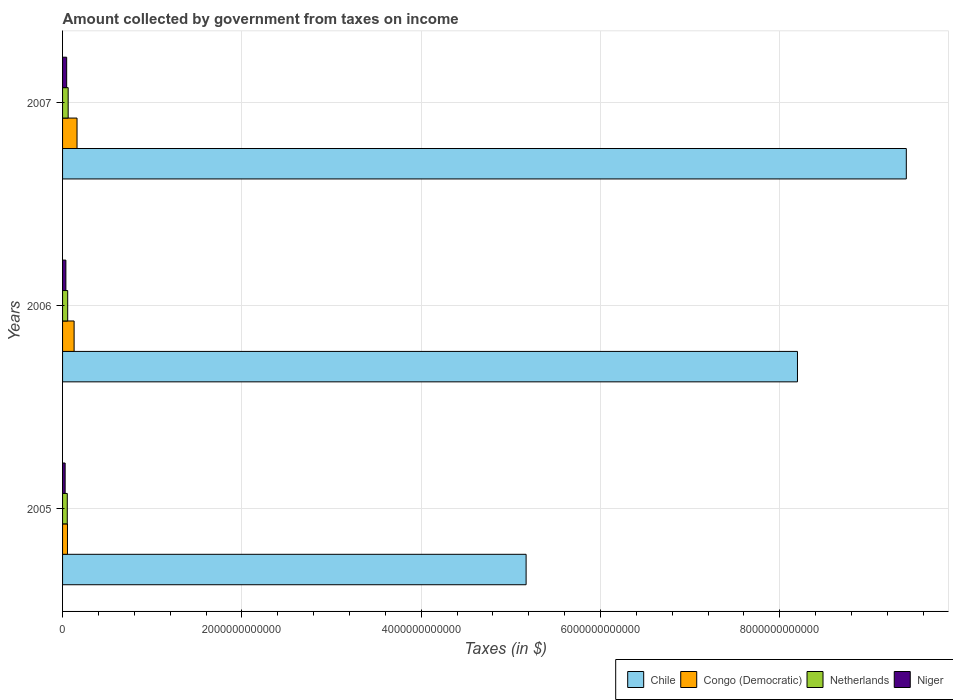How many different coloured bars are there?
Give a very brief answer. 4. How many groups of bars are there?
Offer a very short reply. 3. How many bars are there on the 2nd tick from the top?
Offer a terse response. 4. How many bars are there on the 2nd tick from the bottom?
Make the answer very short. 4. What is the label of the 1st group of bars from the top?
Your response must be concise. 2007. In how many cases, is the number of bars for a given year not equal to the number of legend labels?
Your response must be concise. 0. What is the amount collected by government from taxes on income in Netherlands in 2007?
Your answer should be compact. 6.25e+1. Across all years, what is the maximum amount collected by government from taxes on income in Niger?
Offer a terse response. 4.58e+1. Across all years, what is the minimum amount collected by government from taxes on income in Congo (Democratic)?
Offer a terse response. 5.48e+1. In which year was the amount collected by government from taxes on income in Chile maximum?
Ensure brevity in your answer.  2007. In which year was the amount collected by government from taxes on income in Chile minimum?
Your answer should be compact. 2005. What is the total amount collected by government from taxes on income in Netherlands in the graph?
Offer a terse response. 1.72e+11. What is the difference between the amount collected by government from taxes on income in Netherlands in 2006 and that in 2007?
Keep it short and to the point. -5.07e+09. What is the difference between the amount collected by government from taxes on income in Chile in 2006 and the amount collected by government from taxes on income in Netherlands in 2005?
Your answer should be very brief. 8.15e+12. What is the average amount collected by government from taxes on income in Netherlands per year?
Your answer should be compact. 5.75e+1. In the year 2007, what is the difference between the amount collected by government from taxes on income in Niger and amount collected by government from taxes on income in Netherlands?
Provide a short and direct response. -1.67e+1. What is the ratio of the amount collected by government from taxes on income in Congo (Democratic) in 2006 to that in 2007?
Make the answer very short. 0.8. Is the difference between the amount collected by government from taxes on income in Niger in 2005 and 2006 greater than the difference between the amount collected by government from taxes on income in Netherlands in 2005 and 2006?
Offer a very short reply. No. What is the difference between the highest and the second highest amount collected by government from taxes on income in Niger?
Make the answer very short. 8.88e+09. What is the difference between the highest and the lowest amount collected by government from taxes on income in Netherlands?
Your answer should be compact. 9.82e+09. What does the 2nd bar from the bottom in 2006 represents?
Provide a short and direct response. Congo (Democratic). How many bars are there?
Make the answer very short. 12. How many years are there in the graph?
Offer a terse response. 3. What is the difference between two consecutive major ticks on the X-axis?
Provide a short and direct response. 2.00e+12. Does the graph contain any zero values?
Ensure brevity in your answer.  No. Does the graph contain grids?
Provide a short and direct response. Yes. Where does the legend appear in the graph?
Provide a succinct answer. Bottom right. How many legend labels are there?
Your answer should be very brief. 4. How are the legend labels stacked?
Ensure brevity in your answer.  Horizontal. What is the title of the graph?
Provide a short and direct response. Amount collected by government from taxes on income. What is the label or title of the X-axis?
Your answer should be very brief. Taxes (in $). What is the Taxes (in $) in Chile in 2005?
Your response must be concise. 5.17e+12. What is the Taxes (in $) of Congo (Democratic) in 2005?
Your response must be concise. 5.48e+1. What is the Taxes (in $) in Netherlands in 2005?
Give a very brief answer. 5.26e+1. What is the Taxes (in $) of Niger in 2005?
Ensure brevity in your answer.  2.86e+1. What is the Taxes (in $) in Chile in 2006?
Your answer should be very brief. 8.20e+12. What is the Taxes (in $) of Congo (Democratic) in 2006?
Your response must be concise. 1.29e+11. What is the Taxes (in $) of Netherlands in 2006?
Ensure brevity in your answer.  5.74e+1. What is the Taxes (in $) in Niger in 2006?
Ensure brevity in your answer.  3.69e+1. What is the Taxes (in $) of Chile in 2007?
Provide a succinct answer. 9.41e+12. What is the Taxes (in $) of Congo (Democratic) in 2007?
Offer a terse response. 1.61e+11. What is the Taxes (in $) of Netherlands in 2007?
Give a very brief answer. 6.25e+1. What is the Taxes (in $) in Niger in 2007?
Your answer should be very brief. 4.58e+1. Across all years, what is the maximum Taxes (in $) in Chile?
Give a very brief answer. 9.41e+12. Across all years, what is the maximum Taxes (in $) of Congo (Democratic)?
Your response must be concise. 1.61e+11. Across all years, what is the maximum Taxes (in $) of Netherlands?
Ensure brevity in your answer.  6.25e+1. Across all years, what is the maximum Taxes (in $) in Niger?
Your answer should be compact. 4.58e+1. Across all years, what is the minimum Taxes (in $) in Chile?
Provide a short and direct response. 5.17e+12. Across all years, what is the minimum Taxes (in $) of Congo (Democratic)?
Make the answer very short. 5.48e+1. Across all years, what is the minimum Taxes (in $) in Netherlands?
Your answer should be very brief. 5.26e+1. Across all years, what is the minimum Taxes (in $) of Niger?
Keep it short and to the point. 2.86e+1. What is the total Taxes (in $) in Chile in the graph?
Your answer should be very brief. 2.28e+13. What is the total Taxes (in $) of Congo (Democratic) in the graph?
Ensure brevity in your answer.  3.45e+11. What is the total Taxes (in $) in Netherlands in the graph?
Provide a succinct answer. 1.72e+11. What is the total Taxes (in $) in Niger in the graph?
Offer a terse response. 1.11e+11. What is the difference between the Taxes (in $) in Chile in 2005 and that in 2006?
Keep it short and to the point. -3.03e+12. What is the difference between the Taxes (in $) of Congo (Democratic) in 2005 and that in 2006?
Provide a short and direct response. -7.40e+1. What is the difference between the Taxes (in $) in Netherlands in 2005 and that in 2006?
Provide a succinct answer. -4.75e+09. What is the difference between the Taxes (in $) in Niger in 2005 and that in 2006?
Your answer should be compact. -8.25e+09. What is the difference between the Taxes (in $) of Chile in 2005 and that in 2007?
Provide a succinct answer. -4.24e+12. What is the difference between the Taxes (in $) in Congo (Democratic) in 2005 and that in 2007?
Your answer should be very brief. -1.07e+11. What is the difference between the Taxes (in $) in Netherlands in 2005 and that in 2007?
Your response must be concise. -9.82e+09. What is the difference between the Taxes (in $) of Niger in 2005 and that in 2007?
Your response must be concise. -1.71e+1. What is the difference between the Taxes (in $) in Chile in 2006 and that in 2007?
Offer a very short reply. -1.21e+12. What is the difference between the Taxes (in $) of Congo (Democratic) in 2006 and that in 2007?
Your response must be concise. -3.26e+1. What is the difference between the Taxes (in $) in Netherlands in 2006 and that in 2007?
Provide a succinct answer. -5.07e+09. What is the difference between the Taxes (in $) of Niger in 2006 and that in 2007?
Offer a terse response. -8.88e+09. What is the difference between the Taxes (in $) in Chile in 2005 and the Taxes (in $) in Congo (Democratic) in 2006?
Offer a terse response. 5.04e+12. What is the difference between the Taxes (in $) in Chile in 2005 and the Taxes (in $) in Netherlands in 2006?
Provide a succinct answer. 5.11e+12. What is the difference between the Taxes (in $) in Chile in 2005 and the Taxes (in $) in Niger in 2006?
Make the answer very short. 5.13e+12. What is the difference between the Taxes (in $) in Congo (Democratic) in 2005 and the Taxes (in $) in Netherlands in 2006?
Your answer should be compact. -2.63e+09. What is the difference between the Taxes (in $) of Congo (Democratic) in 2005 and the Taxes (in $) of Niger in 2006?
Keep it short and to the point. 1.79e+1. What is the difference between the Taxes (in $) in Netherlands in 2005 and the Taxes (in $) in Niger in 2006?
Your answer should be compact. 1.57e+1. What is the difference between the Taxes (in $) in Chile in 2005 and the Taxes (in $) in Congo (Democratic) in 2007?
Give a very brief answer. 5.01e+12. What is the difference between the Taxes (in $) in Chile in 2005 and the Taxes (in $) in Netherlands in 2007?
Ensure brevity in your answer.  5.11e+12. What is the difference between the Taxes (in $) in Chile in 2005 and the Taxes (in $) in Niger in 2007?
Provide a short and direct response. 5.13e+12. What is the difference between the Taxes (in $) in Congo (Democratic) in 2005 and the Taxes (in $) in Netherlands in 2007?
Your response must be concise. -7.70e+09. What is the difference between the Taxes (in $) in Congo (Democratic) in 2005 and the Taxes (in $) in Niger in 2007?
Your answer should be compact. 8.99e+09. What is the difference between the Taxes (in $) in Netherlands in 2005 and the Taxes (in $) in Niger in 2007?
Give a very brief answer. 6.86e+09. What is the difference between the Taxes (in $) in Chile in 2006 and the Taxes (in $) in Congo (Democratic) in 2007?
Keep it short and to the point. 8.04e+12. What is the difference between the Taxes (in $) in Chile in 2006 and the Taxes (in $) in Netherlands in 2007?
Give a very brief answer. 8.14e+12. What is the difference between the Taxes (in $) in Chile in 2006 and the Taxes (in $) in Niger in 2007?
Offer a very short reply. 8.15e+12. What is the difference between the Taxes (in $) in Congo (Democratic) in 2006 and the Taxes (in $) in Netherlands in 2007?
Provide a succinct answer. 6.63e+1. What is the difference between the Taxes (in $) of Congo (Democratic) in 2006 and the Taxes (in $) of Niger in 2007?
Your answer should be compact. 8.30e+1. What is the difference between the Taxes (in $) in Netherlands in 2006 and the Taxes (in $) in Niger in 2007?
Provide a succinct answer. 1.16e+1. What is the average Taxes (in $) of Chile per year?
Provide a short and direct response. 7.59e+12. What is the average Taxes (in $) in Congo (Democratic) per year?
Your answer should be compact. 1.15e+11. What is the average Taxes (in $) of Netherlands per year?
Provide a succinct answer. 5.75e+1. What is the average Taxes (in $) of Niger per year?
Keep it short and to the point. 3.71e+1. In the year 2005, what is the difference between the Taxes (in $) of Chile and Taxes (in $) of Congo (Democratic)?
Your response must be concise. 5.12e+12. In the year 2005, what is the difference between the Taxes (in $) of Chile and Taxes (in $) of Netherlands?
Provide a succinct answer. 5.12e+12. In the year 2005, what is the difference between the Taxes (in $) in Chile and Taxes (in $) in Niger?
Offer a terse response. 5.14e+12. In the year 2005, what is the difference between the Taxes (in $) of Congo (Democratic) and Taxes (in $) of Netherlands?
Keep it short and to the point. 2.12e+09. In the year 2005, what is the difference between the Taxes (in $) of Congo (Democratic) and Taxes (in $) of Niger?
Your answer should be very brief. 2.61e+1. In the year 2005, what is the difference between the Taxes (in $) of Netherlands and Taxes (in $) of Niger?
Keep it short and to the point. 2.40e+1. In the year 2006, what is the difference between the Taxes (in $) in Chile and Taxes (in $) in Congo (Democratic)?
Provide a short and direct response. 8.07e+12. In the year 2006, what is the difference between the Taxes (in $) in Chile and Taxes (in $) in Netherlands?
Keep it short and to the point. 8.14e+12. In the year 2006, what is the difference between the Taxes (in $) of Chile and Taxes (in $) of Niger?
Your answer should be compact. 8.16e+12. In the year 2006, what is the difference between the Taxes (in $) in Congo (Democratic) and Taxes (in $) in Netherlands?
Offer a terse response. 7.14e+1. In the year 2006, what is the difference between the Taxes (in $) in Congo (Democratic) and Taxes (in $) in Niger?
Your response must be concise. 9.19e+1. In the year 2006, what is the difference between the Taxes (in $) in Netherlands and Taxes (in $) in Niger?
Offer a terse response. 2.05e+1. In the year 2007, what is the difference between the Taxes (in $) of Chile and Taxes (in $) of Congo (Democratic)?
Keep it short and to the point. 9.25e+12. In the year 2007, what is the difference between the Taxes (in $) in Chile and Taxes (in $) in Netherlands?
Your answer should be very brief. 9.35e+12. In the year 2007, what is the difference between the Taxes (in $) of Chile and Taxes (in $) of Niger?
Your answer should be compact. 9.37e+12. In the year 2007, what is the difference between the Taxes (in $) in Congo (Democratic) and Taxes (in $) in Netherlands?
Keep it short and to the point. 9.89e+1. In the year 2007, what is the difference between the Taxes (in $) of Congo (Democratic) and Taxes (in $) of Niger?
Your response must be concise. 1.16e+11. In the year 2007, what is the difference between the Taxes (in $) of Netherlands and Taxes (in $) of Niger?
Make the answer very short. 1.67e+1. What is the ratio of the Taxes (in $) in Chile in 2005 to that in 2006?
Offer a very short reply. 0.63. What is the ratio of the Taxes (in $) in Congo (Democratic) in 2005 to that in 2006?
Provide a succinct answer. 0.43. What is the ratio of the Taxes (in $) of Netherlands in 2005 to that in 2006?
Provide a short and direct response. 0.92. What is the ratio of the Taxes (in $) of Niger in 2005 to that in 2006?
Offer a terse response. 0.78. What is the ratio of the Taxes (in $) in Chile in 2005 to that in 2007?
Your response must be concise. 0.55. What is the ratio of the Taxes (in $) in Congo (Democratic) in 2005 to that in 2007?
Provide a short and direct response. 0.34. What is the ratio of the Taxes (in $) of Netherlands in 2005 to that in 2007?
Offer a terse response. 0.84. What is the ratio of the Taxes (in $) in Niger in 2005 to that in 2007?
Your answer should be compact. 0.63. What is the ratio of the Taxes (in $) of Chile in 2006 to that in 2007?
Your answer should be very brief. 0.87. What is the ratio of the Taxes (in $) in Congo (Democratic) in 2006 to that in 2007?
Give a very brief answer. 0.8. What is the ratio of the Taxes (in $) in Netherlands in 2006 to that in 2007?
Provide a short and direct response. 0.92. What is the ratio of the Taxes (in $) in Niger in 2006 to that in 2007?
Ensure brevity in your answer.  0.81. What is the difference between the highest and the second highest Taxes (in $) of Chile?
Make the answer very short. 1.21e+12. What is the difference between the highest and the second highest Taxes (in $) in Congo (Democratic)?
Offer a terse response. 3.26e+1. What is the difference between the highest and the second highest Taxes (in $) in Netherlands?
Provide a succinct answer. 5.07e+09. What is the difference between the highest and the second highest Taxes (in $) in Niger?
Provide a short and direct response. 8.88e+09. What is the difference between the highest and the lowest Taxes (in $) in Chile?
Ensure brevity in your answer.  4.24e+12. What is the difference between the highest and the lowest Taxes (in $) in Congo (Democratic)?
Give a very brief answer. 1.07e+11. What is the difference between the highest and the lowest Taxes (in $) of Netherlands?
Keep it short and to the point. 9.82e+09. What is the difference between the highest and the lowest Taxes (in $) of Niger?
Give a very brief answer. 1.71e+1. 